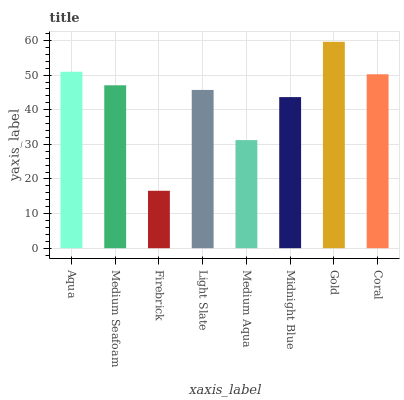Is Medium Seafoam the minimum?
Answer yes or no. No. Is Medium Seafoam the maximum?
Answer yes or no. No. Is Aqua greater than Medium Seafoam?
Answer yes or no. Yes. Is Medium Seafoam less than Aqua?
Answer yes or no. Yes. Is Medium Seafoam greater than Aqua?
Answer yes or no. No. Is Aqua less than Medium Seafoam?
Answer yes or no. No. Is Medium Seafoam the high median?
Answer yes or no. Yes. Is Light Slate the low median?
Answer yes or no. Yes. Is Gold the high median?
Answer yes or no. No. Is Coral the low median?
Answer yes or no. No. 